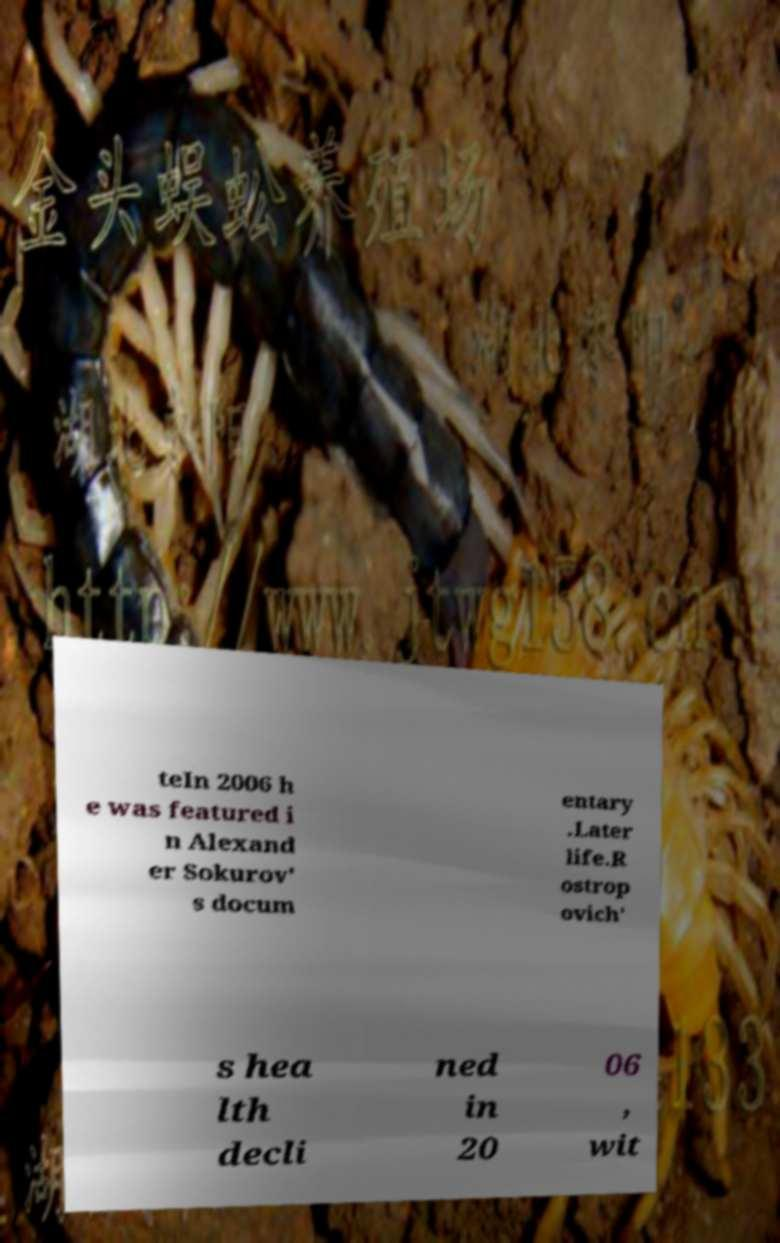Please read and relay the text visible in this image. What does it say? teIn 2006 h e was featured i n Alexand er Sokurov' s docum entary .Later life.R ostrop ovich' s hea lth decli ned in 20 06 , wit 